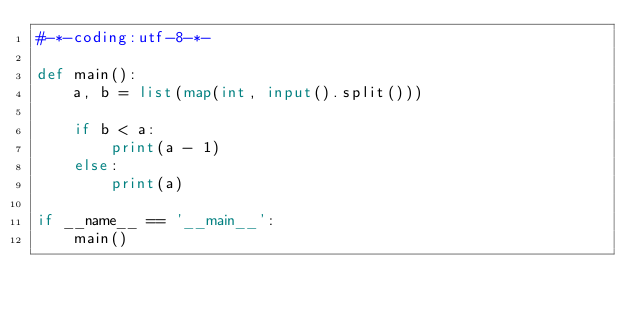<code> <loc_0><loc_0><loc_500><loc_500><_Python_>#-*-coding:utf-8-*-

def main():
    a, b = list(map(int, input().split()))

    if b < a:
        print(a - 1)
    else:
        print(a)

if __name__ == '__main__':
    main()</code> 